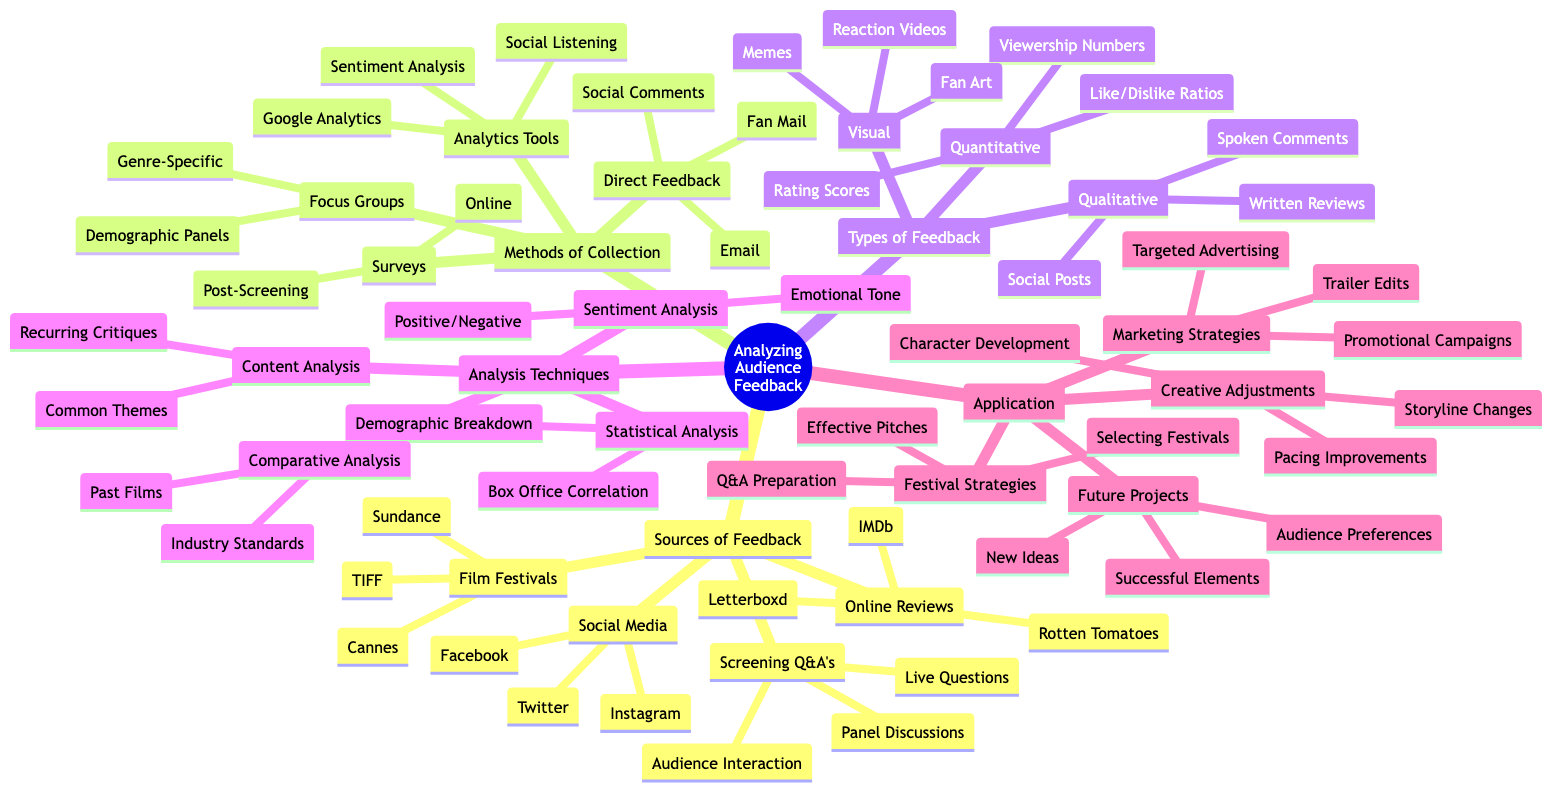What are the sources of feedback listed in the diagram? The diagram contains a section called "Sources of Feedback," which includes Film Festivals, Social Media, Online Reviews, and Screening Q&A's as the main categories. Each of these categories contains specific platforms or events as sub-nodes.
Answer: Film Festivals, Social Media, Online Reviews, Screening Q&A's How many types of feedback are identified in the mind map? According to the diagram, there are three main types of feedback identified under the "Types of Feedback" section: Quantitative, Qualitative, and Visual. Each type has specific examples provided in sub-nodes.
Answer: 3 What is one method of collecting direct feedback? The "Methods of Collection" section includes various methods, and under the "Direct Feedback" category, options such as Email Responses, Fan Mail, and Comments on Social Media are listed. Any of these can be considered direct feedback.
Answer: Email Responses Which analysis technique looks for common themes in feedback? In the "Analysis Techniques" section, "Content Analysis" is specifically mentioned as the technique that involves extracting common themes and recurring critiques in the audience feedback.
Answer: Content Analysis How do qualitative and quantitative feedback types differ? The diagram clarifies that "Quantitative" feedback deals with numerical values and statistics (like Rating Scores and Viewership Numbers), whereas "Qualitative" feedback includes descriptive writing such as Written Reviews and Social Media Posts. This reveals two distinct categories of audience feedback.
Answer: Nature of data What is one creative adjustment that can be made based on audience feedback? Under the "Application" section, "Creative Adjustments" lists specific elements that can be modified based on the feedback, including Storyline Changes, Character Development, and Pacing Improvements. Any of these is an example of a creative adjustment.
Answer: Storyline Changes Which type of feedback includes memes related to the film? In the "Types of Feedback" section, the "Visual" type includes examples like Reaction Videos, Fan Art, and Memes Related to the Film, clearly categorizing memes under visual feedback.
Answer: Memes Related to the Film What is one way to utilize audience feedback in future projects? The diagram provides information in the "Application" section, stating "Future Projects" can benefit from audience feedback by understanding Audience Preferences, identifying Successful Elements, and inspiring New Ideas. Any of these would be valid.
Answer: Audience Preferences 